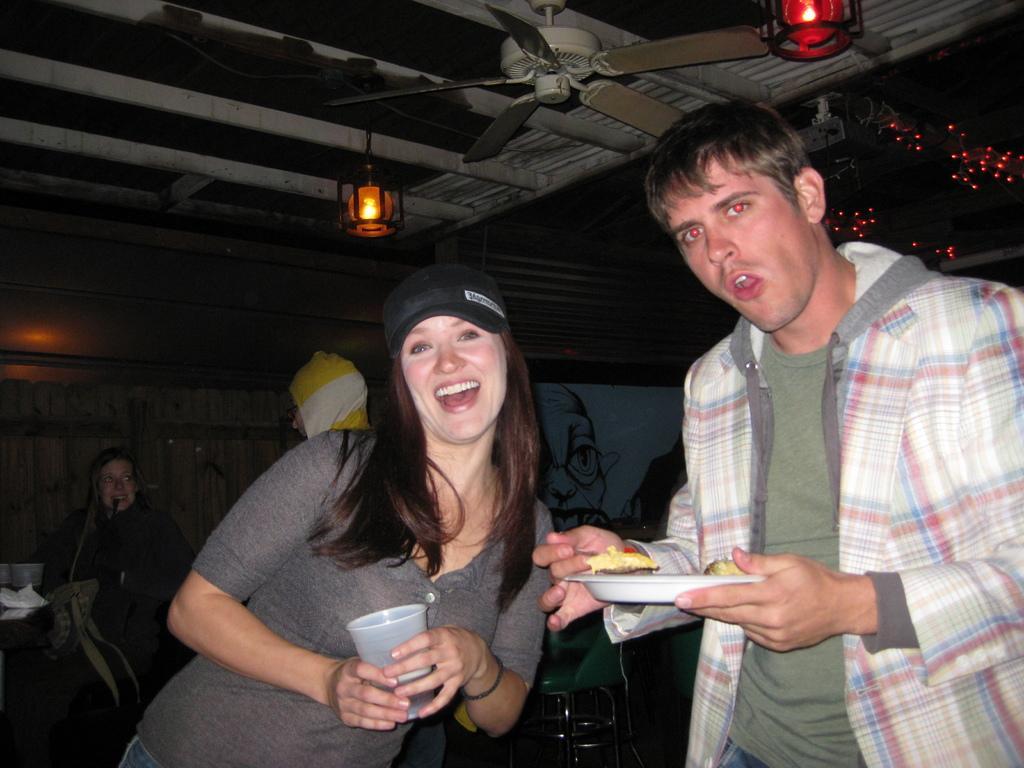Please provide a concise description of this image. In the middle of the image two persons are standing and holding a plate and glass. Behind them few people are standing. At the top of the image we can see ceiling, fans and lights. 